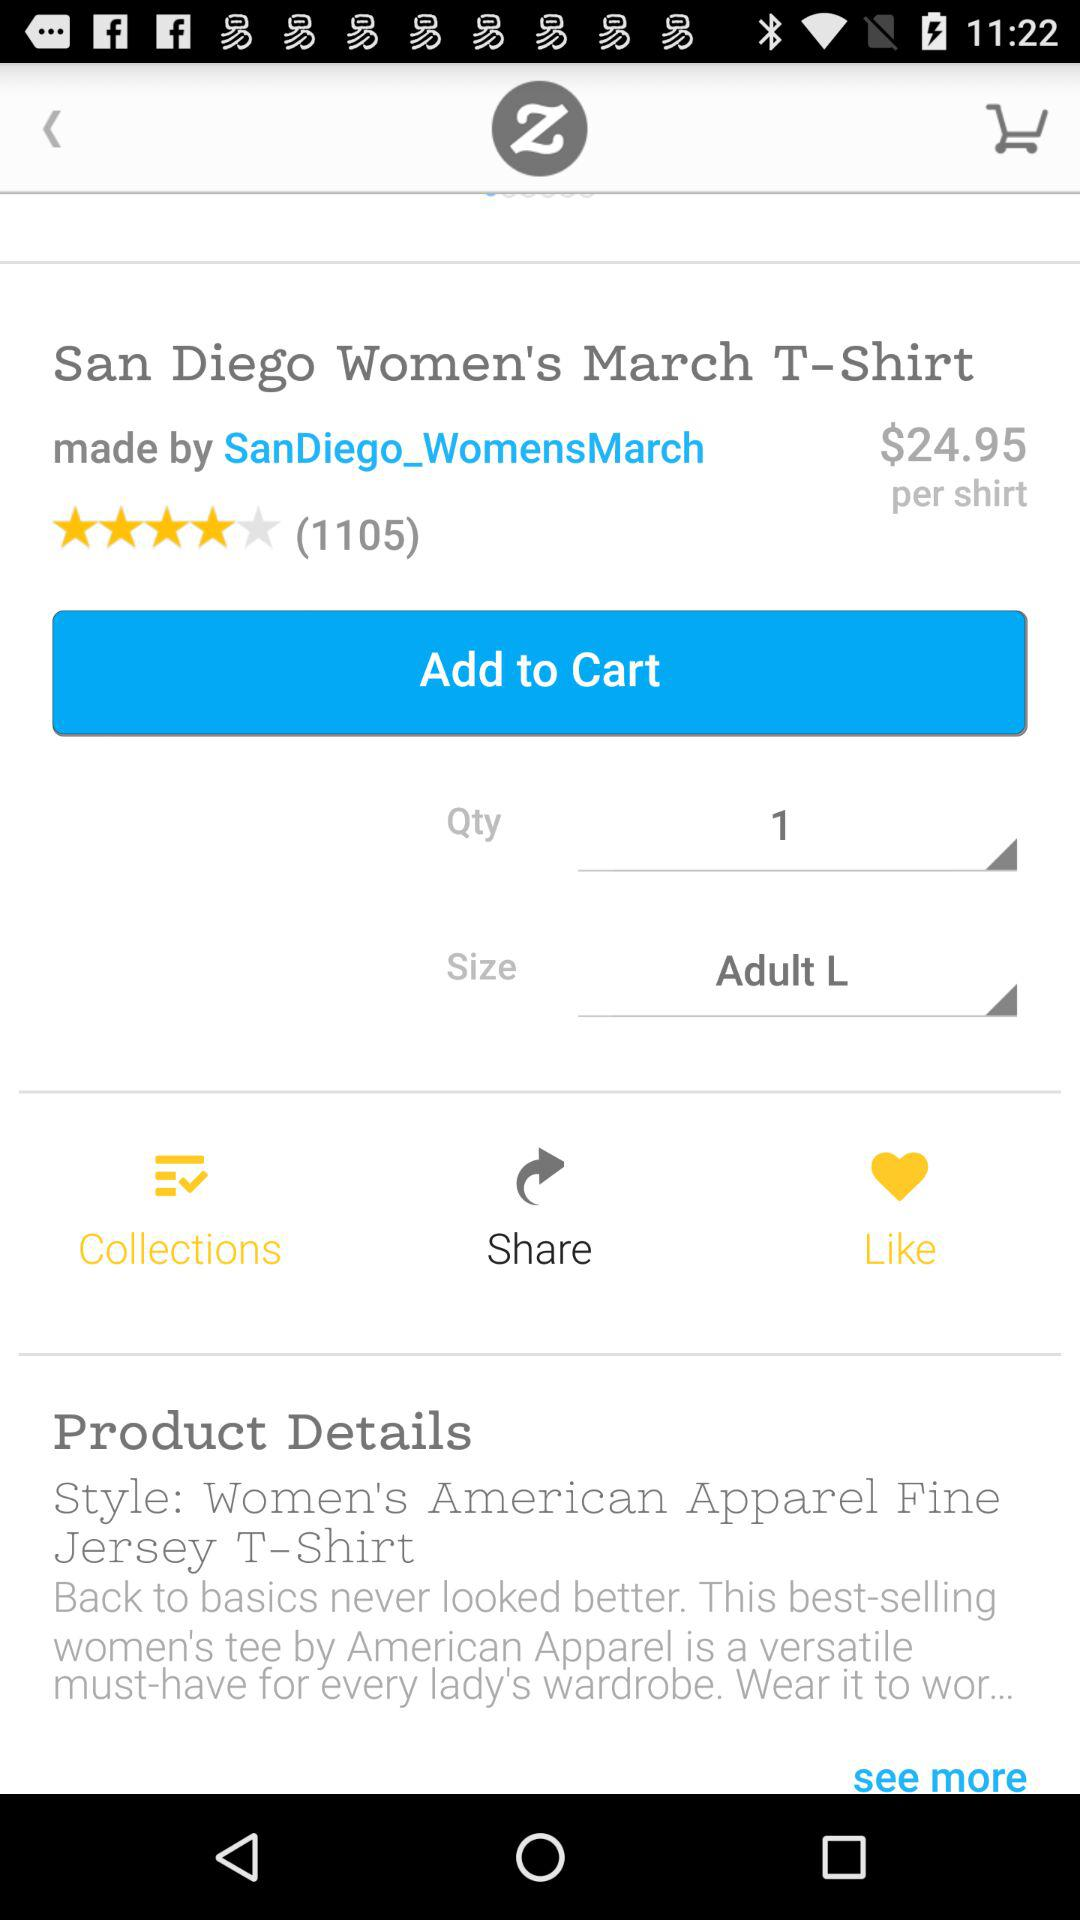What's the style of the product? The style is "Women's American Apparel Fine Jersey T - Shirt". 